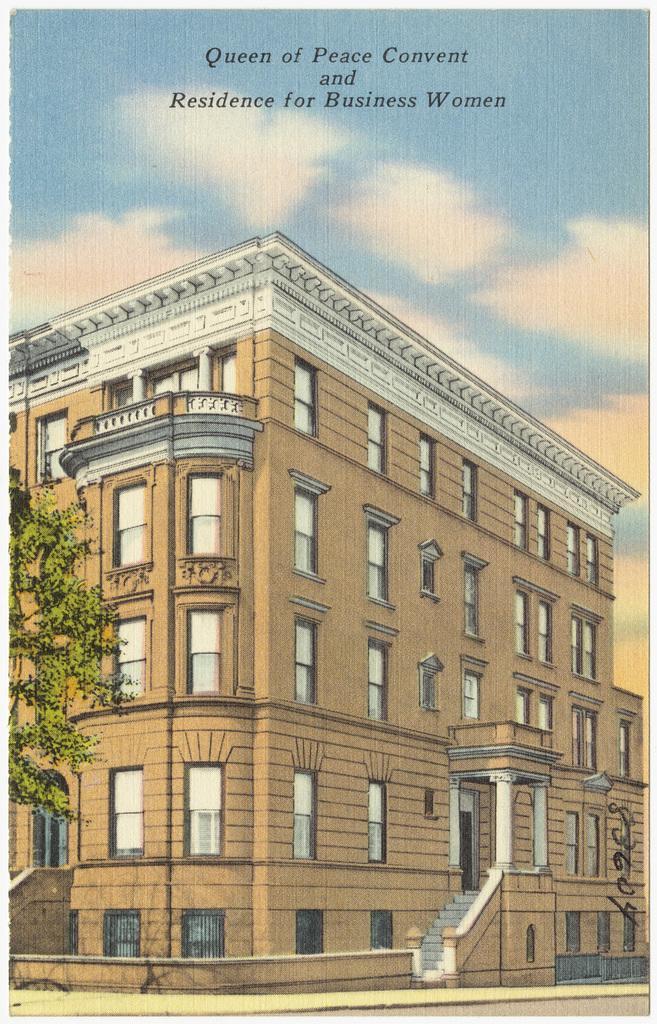Could you give a brief overview of what you see in this image? In this picture there is a poster. In the poster I can see the building. On the left I can see the trees. At the top of the poster I can see the watermark, sky and clouds. 